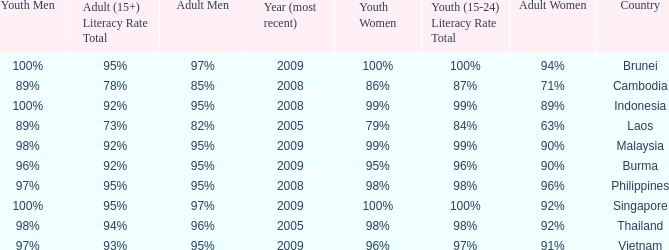What country has a Youth (15-24) Literacy Rate Total of 99%, and a Youth Men of 98%? Malaysia. 